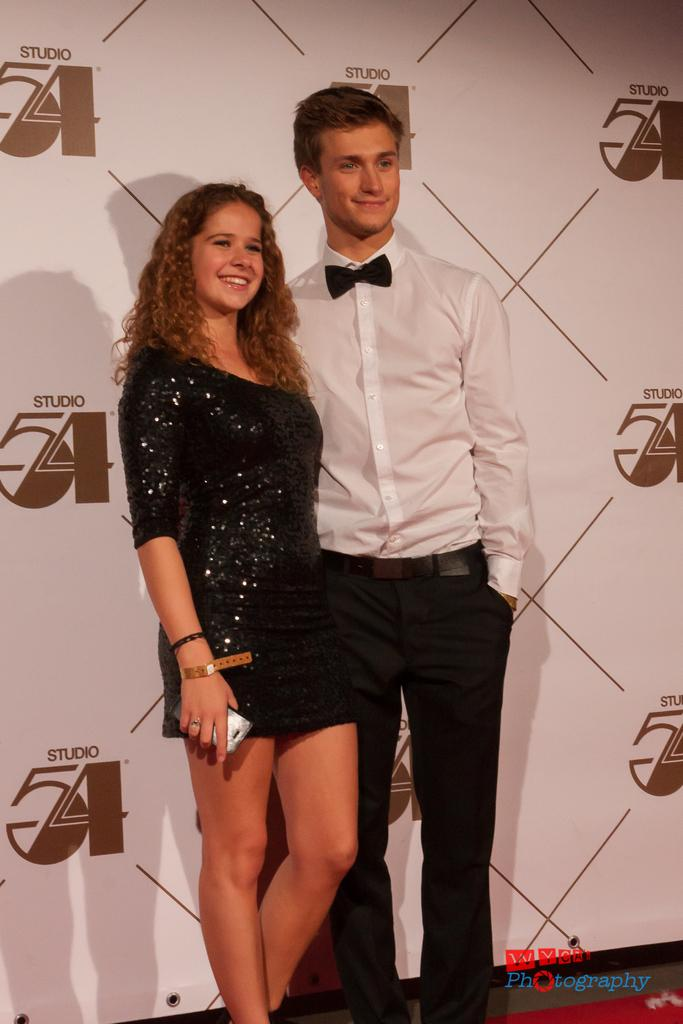How many people are in the image? There are two persons in the image. Where are the two persons located? The two persons are standing on a stage. What can be seen in the background of the image? There is a poster in the background of the image. Is there steam coming from the person on the left side of the stage? There is no steam present in the image, and no person is specifically mentioned as being on the left side of the stage. 